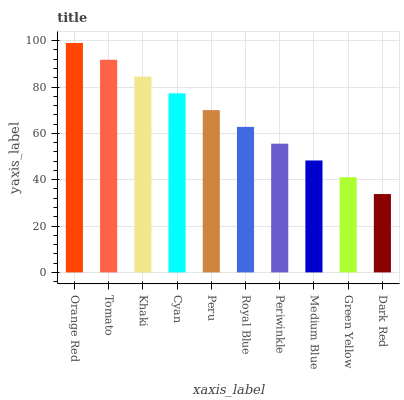Is Dark Red the minimum?
Answer yes or no. Yes. Is Orange Red the maximum?
Answer yes or no. Yes. Is Tomato the minimum?
Answer yes or no. No. Is Tomato the maximum?
Answer yes or no. No. Is Orange Red greater than Tomato?
Answer yes or no. Yes. Is Tomato less than Orange Red?
Answer yes or no. Yes. Is Tomato greater than Orange Red?
Answer yes or no. No. Is Orange Red less than Tomato?
Answer yes or no. No. Is Peru the high median?
Answer yes or no. Yes. Is Royal Blue the low median?
Answer yes or no. Yes. Is Green Yellow the high median?
Answer yes or no. No. Is Periwinkle the low median?
Answer yes or no. No. 